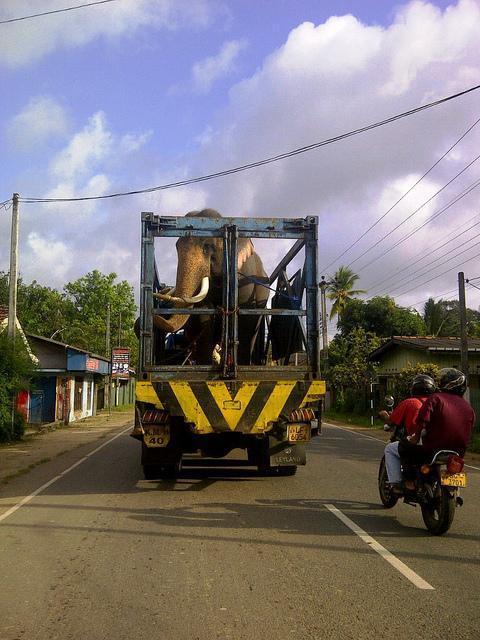Evaluate: Does the caption "The elephant is inside the truck." match the image?
Answer yes or no. Yes. Verify the accuracy of this image caption: "The truck is surrounding the elephant.".
Answer yes or no. Yes. Evaluate: Does the caption "The truck contains the elephant." match the image?
Answer yes or no. Yes. 